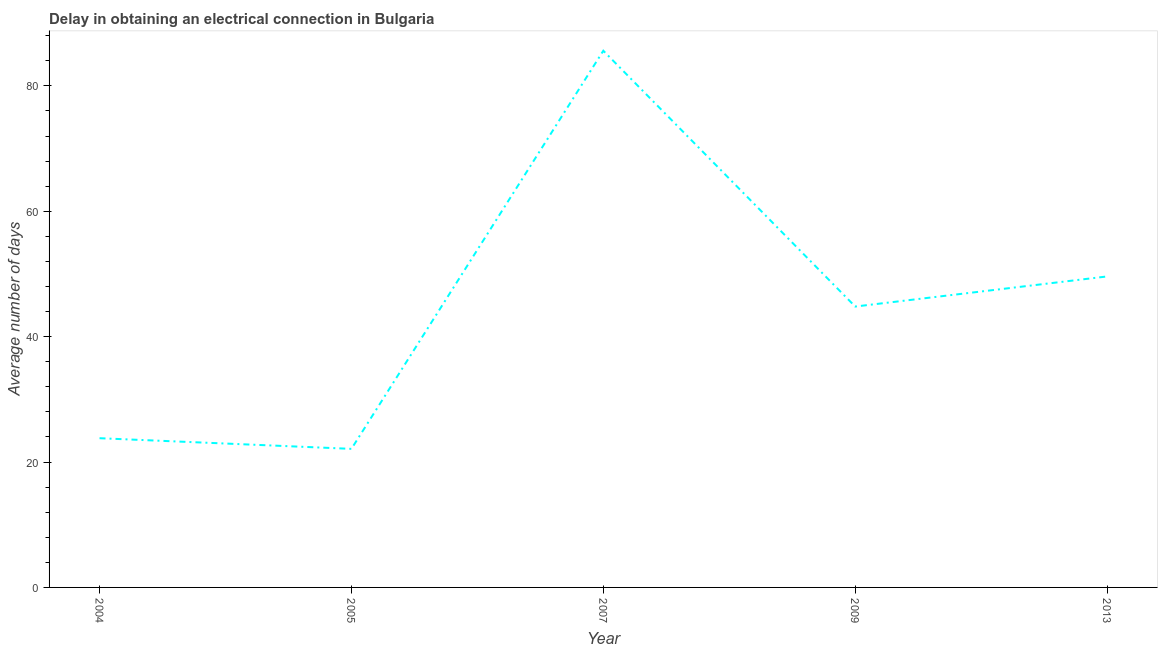What is the dalay in electrical connection in 2007?
Make the answer very short. 85.6. Across all years, what is the maximum dalay in electrical connection?
Provide a short and direct response. 85.6. Across all years, what is the minimum dalay in electrical connection?
Make the answer very short. 22.1. In which year was the dalay in electrical connection minimum?
Give a very brief answer. 2005. What is the sum of the dalay in electrical connection?
Offer a very short reply. 225.9. What is the difference between the dalay in electrical connection in 2005 and 2007?
Ensure brevity in your answer.  -63.5. What is the average dalay in electrical connection per year?
Your answer should be very brief. 45.18. What is the median dalay in electrical connection?
Your response must be concise. 44.8. In how many years, is the dalay in electrical connection greater than 32 days?
Keep it short and to the point. 3. Do a majority of the years between 2004 and 2007 (inclusive) have dalay in electrical connection greater than 12 days?
Give a very brief answer. Yes. What is the ratio of the dalay in electrical connection in 2007 to that in 2009?
Your response must be concise. 1.91. What is the difference between the highest and the second highest dalay in electrical connection?
Keep it short and to the point. 36. What is the difference between the highest and the lowest dalay in electrical connection?
Make the answer very short. 63.5. In how many years, is the dalay in electrical connection greater than the average dalay in electrical connection taken over all years?
Make the answer very short. 2. What is the difference between two consecutive major ticks on the Y-axis?
Make the answer very short. 20. Does the graph contain grids?
Your answer should be compact. No. What is the title of the graph?
Your answer should be compact. Delay in obtaining an electrical connection in Bulgaria. What is the label or title of the X-axis?
Provide a short and direct response. Year. What is the label or title of the Y-axis?
Keep it short and to the point. Average number of days. What is the Average number of days of 2004?
Your answer should be very brief. 23.8. What is the Average number of days in 2005?
Provide a short and direct response. 22.1. What is the Average number of days of 2007?
Keep it short and to the point. 85.6. What is the Average number of days in 2009?
Provide a succinct answer. 44.8. What is the Average number of days of 2013?
Your response must be concise. 49.6. What is the difference between the Average number of days in 2004 and 2007?
Provide a short and direct response. -61.8. What is the difference between the Average number of days in 2004 and 2013?
Your answer should be very brief. -25.8. What is the difference between the Average number of days in 2005 and 2007?
Ensure brevity in your answer.  -63.5. What is the difference between the Average number of days in 2005 and 2009?
Ensure brevity in your answer.  -22.7. What is the difference between the Average number of days in 2005 and 2013?
Ensure brevity in your answer.  -27.5. What is the difference between the Average number of days in 2007 and 2009?
Offer a very short reply. 40.8. What is the difference between the Average number of days in 2007 and 2013?
Keep it short and to the point. 36. What is the ratio of the Average number of days in 2004 to that in 2005?
Make the answer very short. 1.08. What is the ratio of the Average number of days in 2004 to that in 2007?
Ensure brevity in your answer.  0.28. What is the ratio of the Average number of days in 2004 to that in 2009?
Provide a short and direct response. 0.53. What is the ratio of the Average number of days in 2004 to that in 2013?
Offer a terse response. 0.48. What is the ratio of the Average number of days in 2005 to that in 2007?
Your answer should be very brief. 0.26. What is the ratio of the Average number of days in 2005 to that in 2009?
Your response must be concise. 0.49. What is the ratio of the Average number of days in 2005 to that in 2013?
Make the answer very short. 0.45. What is the ratio of the Average number of days in 2007 to that in 2009?
Offer a very short reply. 1.91. What is the ratio of the Average number of days in 2007 to that in 2013?
Give a very brief answer. 1.73. What is the ratio of the Average number of days in 2009 to that in 2013?
Your answer should be compact. 0.9. 